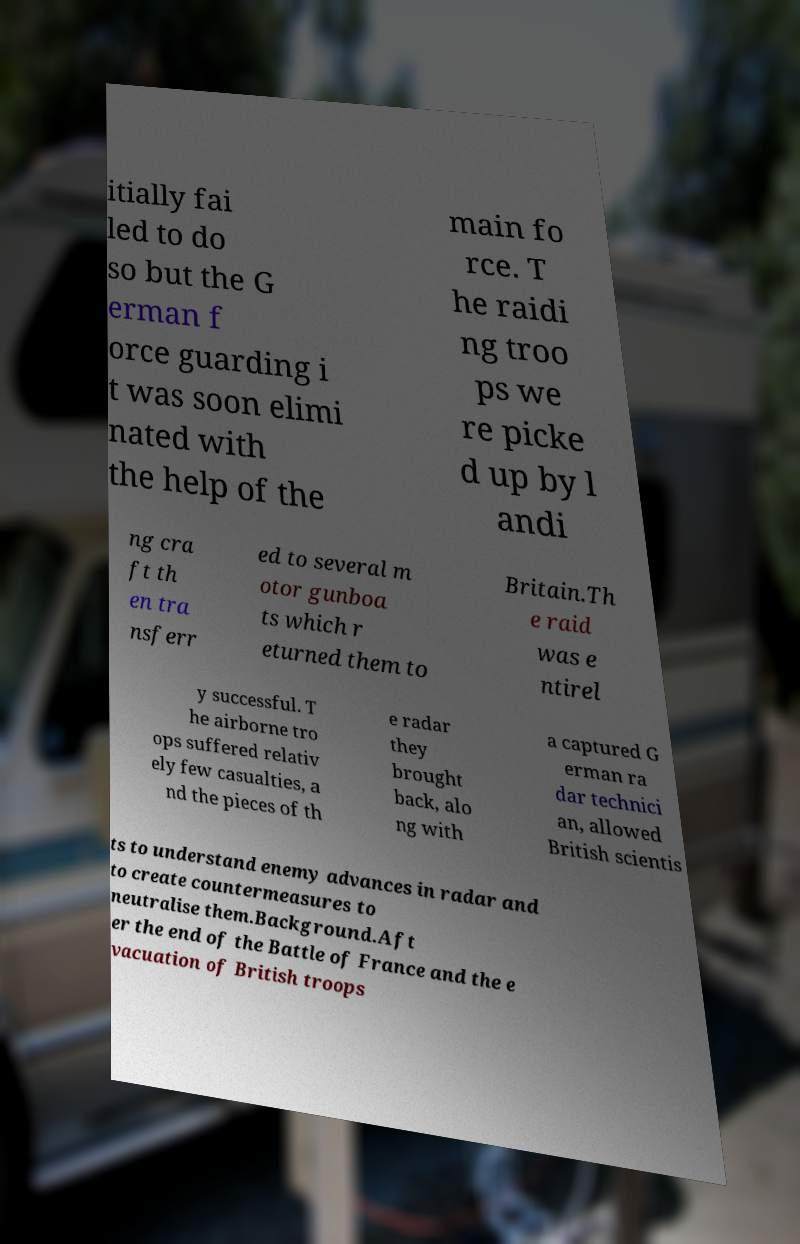Could you assist in decoding the text presented in this image and type it out clearly? itially fai led to do so but the G erman f orce guarding i t was soon elimi nated with the help of the main fo rce. T he raidi ng troo ps we re picke d up by l andi ng cra ft th en tra nsferr ed to several m otor gunboa ts which r eturned them to Britain.Th e raid was e ntirel y successful. T he airborne tro ops suffered relativ ely few casualties, a nd the pieces of th e radar they brought back, alo ng with a captured G erman ra dar technici an, allowed British scientis ts to understand enemy advances in radar and to create countermeasures to neutralise them.Background.Aft er the end of the Battle of France and the e vacuation of British troops 